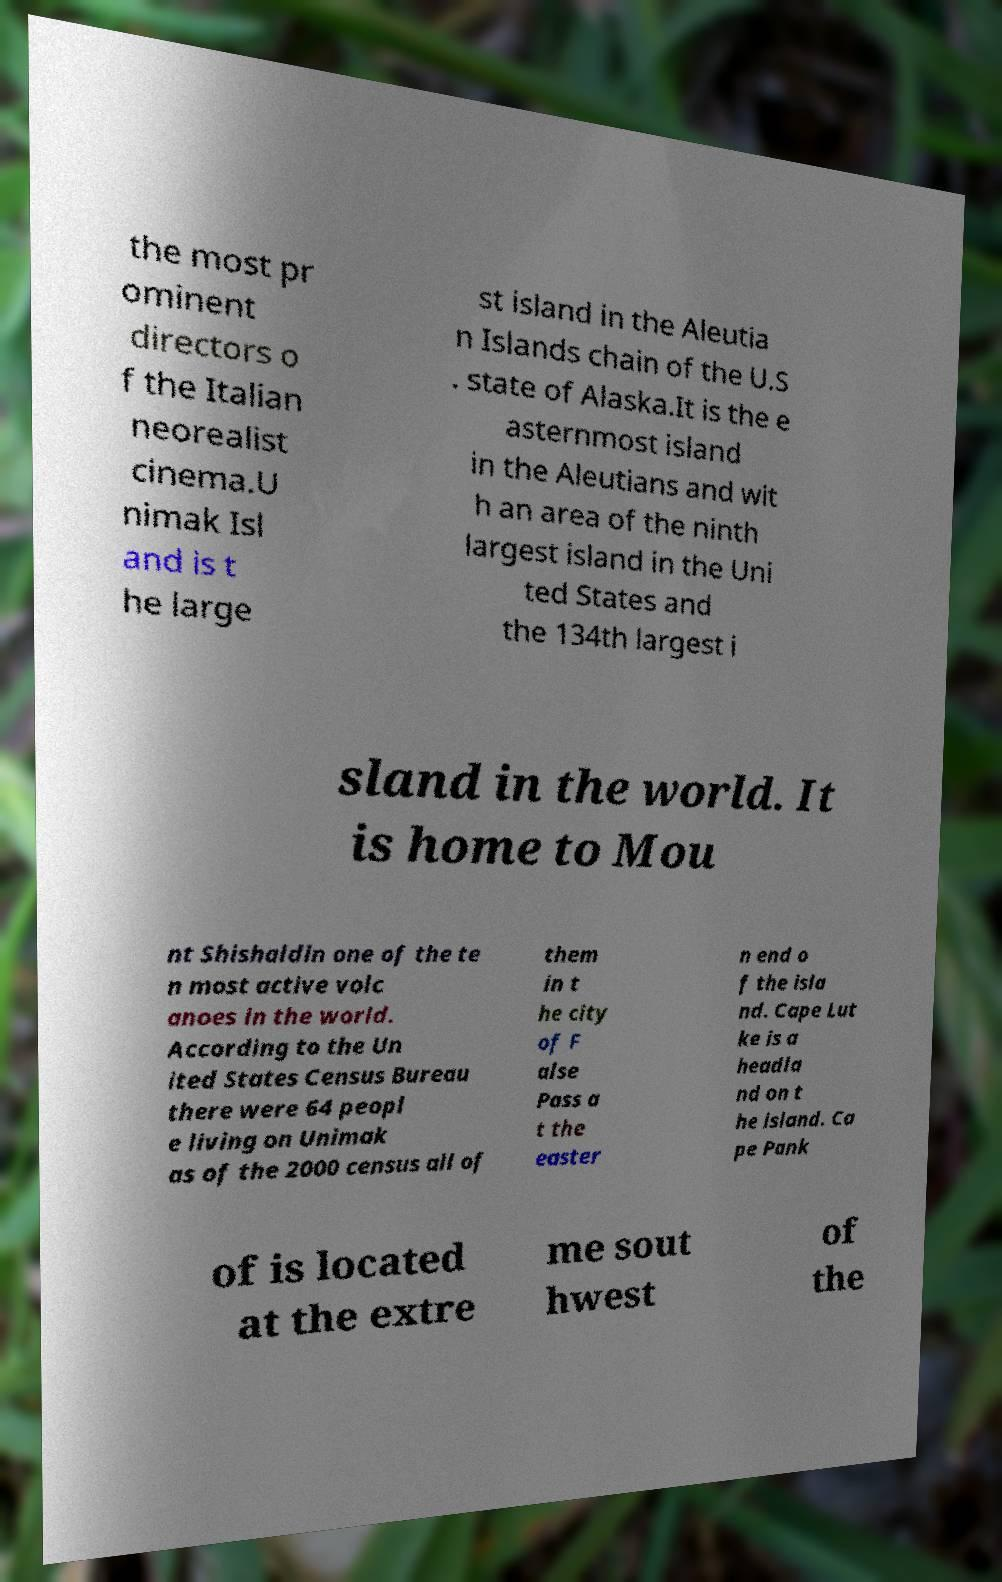Could you extract and type out the text from this image? the most pr ominent directors o f the Italian neorealist cinema.U nimak Isl and is t he large st island in the Aleutia n Islands chain of the U.S . state of Alaska.It is the e asternmost island in the Aleutians and wit h an area of the ninth largest island in the Uni ted States and the 134th largest i sland in the world. It is home to Mou nt Shishaldin one of the te n most active volc anoes in the world. According to the Un ited States Census Bureau there were 64 peopl e living on Unimak as of the 2000 census all of them in t he city of F alse Pass a t the easter n end o f the isla nd. Cape Lut ke is a headla nd on t he island. Ca pe Pank of is located at the extre me sout hwest of the 